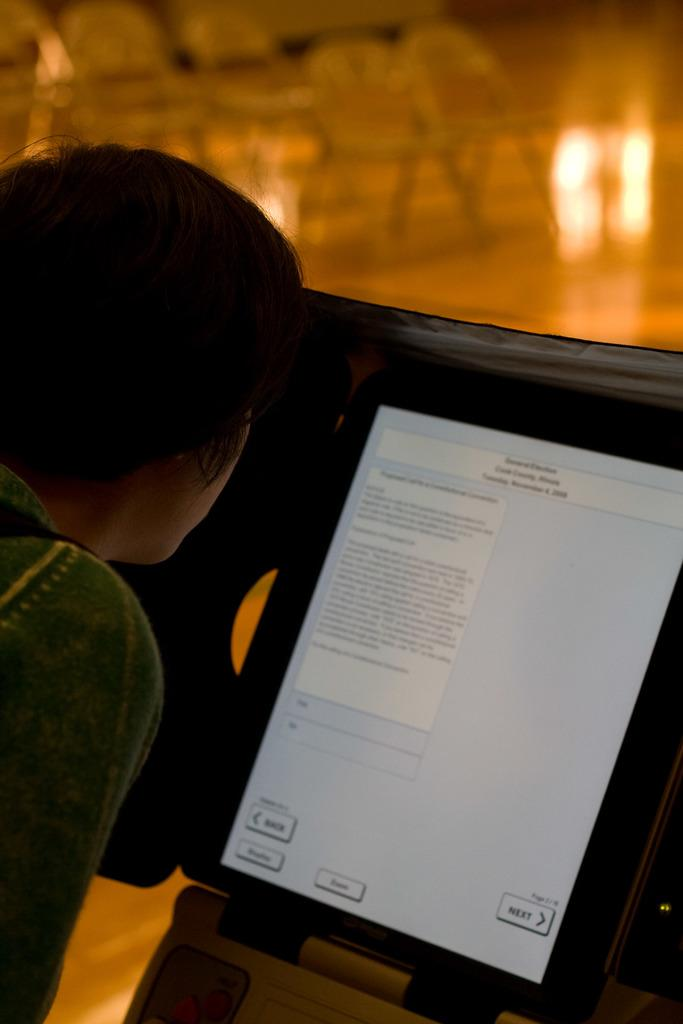What is located on the left side of the image? There is a person on the left side of the image. What is in front of the person? There is a screen in front of the person. What can be seen on the screen? There is something written on the screen. How would you describe the background of the image? The background of the image is blurred. What type of cough medicine is being distributed at the club in the image? There is no mention of cough medicine or a club in the image; it features a person with a screen in front of them and a blurred background. 